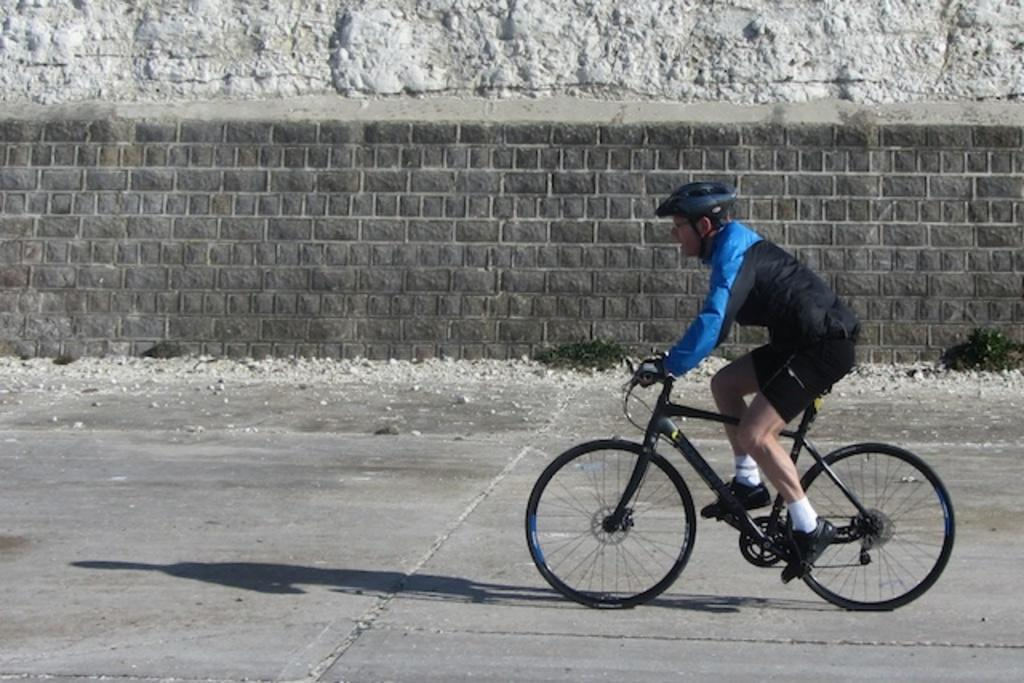Where was the image taken? The image is taken on a road. What is the main subject in the image? There is a man riding a bicycle in the center of the image. Where is the man riding the bicycle? The man is on the road. What can be seen beside the road? There is a wall beside the road. What type of vegetation is near the wall? There is grass near the wall. Can you hear the man riding the bicycle performing magic tricks in the image? There is no indication of magic tricks or sounds in the image, as it only shows a man riding a bicycle on a road. 